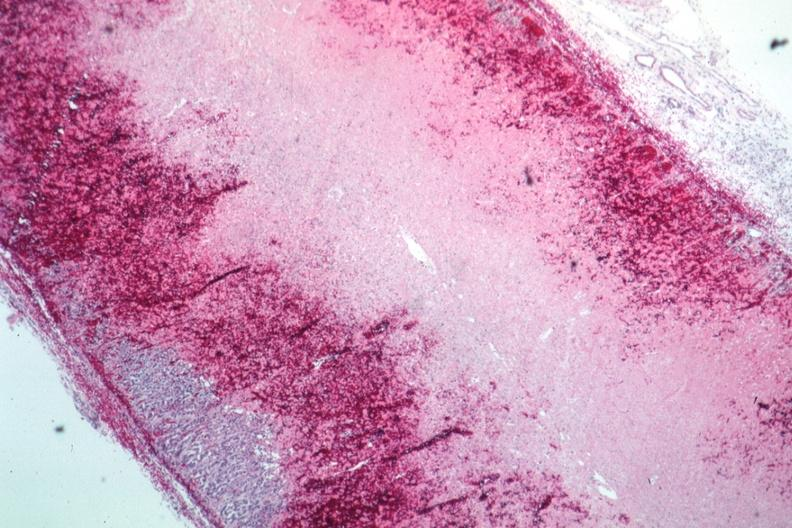what is present?
Answer the question using a single word or phrase. Hemorrhage newborn 